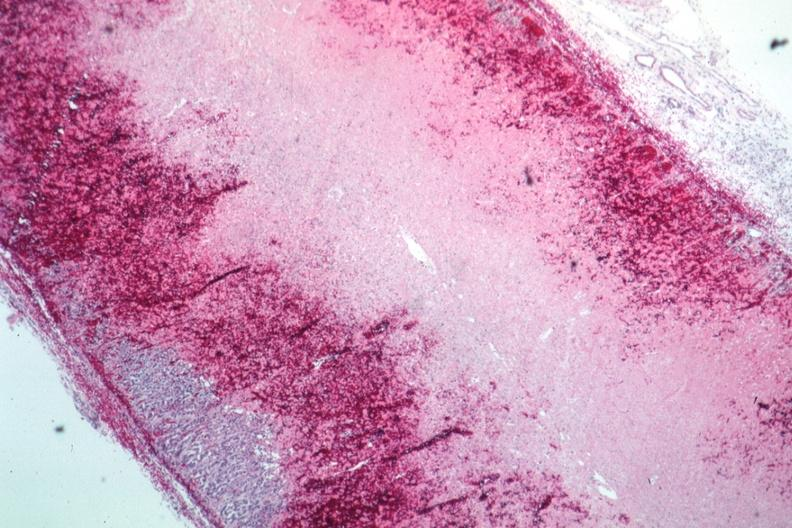what is present?
Answer the question using a single word or phrase. Hemorrhage newborn 